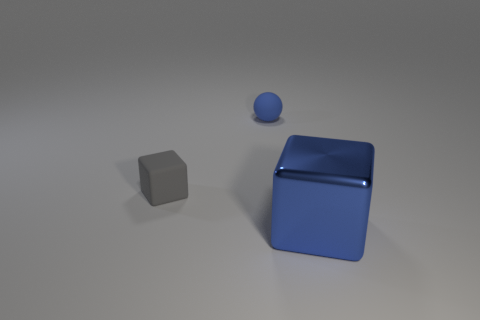What can you infer about the texture of the objects? From the image, the objects appear to have a smooth texture. The way light reflects off the surfaces of the blue blocks and sphere suggests they might have a glossy finish. The gray cube, however, has a less reflective surface, indicating a possible variance in texture, possibly a matte finish. 